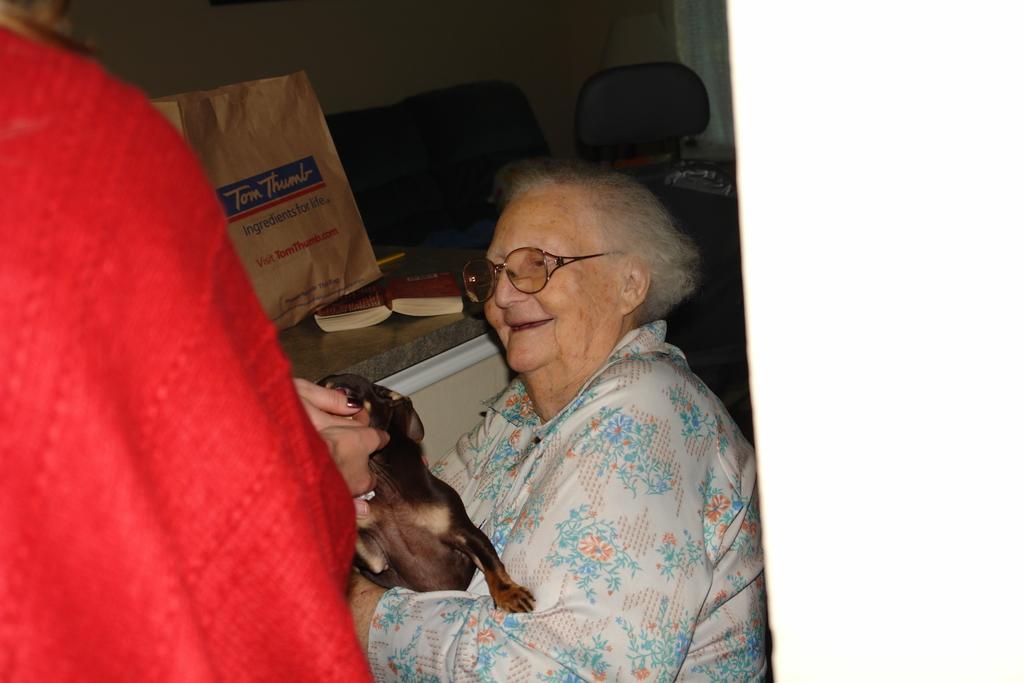Could you give a brief overview of what you see in this image? In the picture I can see an old woman sitting and holding a dog in her hands and there is another person wearing red dress is standing in the left corner and there is a table beside them which has few objects placed on it. 